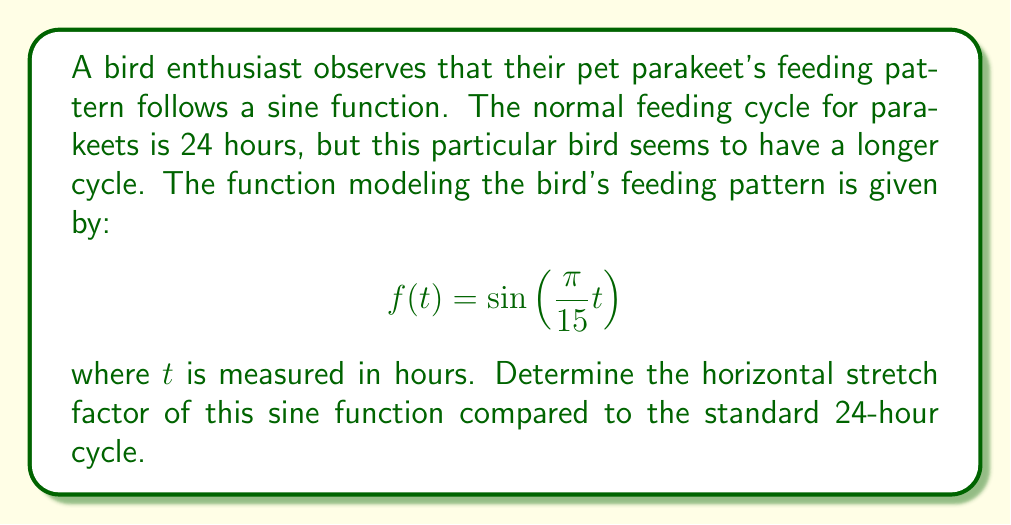Show me your answer to this math problem. To determine the horizontal stretch factor, we need to compare the given function to the standard sine function that would represent a 24-hour cycle.

1) The standard sine function for a 24-hour cycle would be:
   $$f(t) = \sin\left(\frac{2\pi}{24}t\right) = \sin\left(\frac{\pi}{12}t\right)$$

2) The given function is:
   $$f(t) = \sin\left(\frac{\pi}{15}t\right)$$

3) The general form of a horizontally stretched sine function is:
   $$f(t) = \sin\left(\frac{2\pi}{p}t\right)$$
   where $p$ is the period.

4) Comparing the given function to the general form:
   $$\frac{\pi}{15} = \frac{2\pi}{p}$$

5) Solving for $p$:
   $$p = \frac{2\pi}{\frac{\pi}{15}} = 2 \cdot 15 = 30$$

6) This means the period of the given function is 30 hours.

7) The horizontal stretch factor is the ratio of the new period to the original period:
   $$\text{Stretch factor} = \frac{\text{New period}}{\text{Original period}} = \frac{30}{24} = \frac{5}{4} = 1.25$$

Therefore, the horizontal stretch factor is 1.25 or 5/4, meaning the feeding cycle is stretched by 25% compared to the standard 24-hour cycle.
Answer: The horizontal stretch factor is 1.25 or 5/4. 